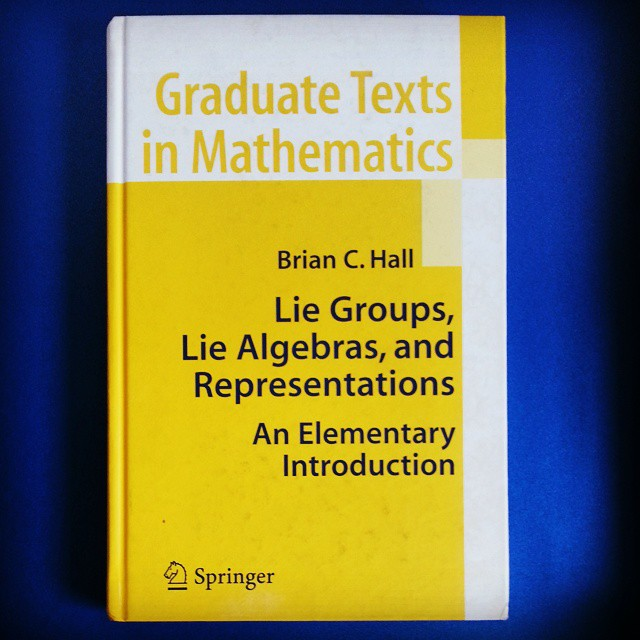Could you create a story involving Lie groups and algebras? Once upon a time, in the land of Mathlandia, there were powerful Guardians of Symmetry, known as the Lie Groups. They maintained harmony and balance in the universe, ensuring every element and force acted predictably. However, hidden among them were the Wise Algebras, Lie Algebras, who knew the secrets of the infinitesimal movements that underpinned the Guardians' strength. Together, they protected the realm from chaos, translating their vast knowledge into Representations – magical runes that could control the fabric of reality. These runes were sought by mathematicians and physicists alike, for they held the keys to unlocking the deepest mysteries of the universe. 